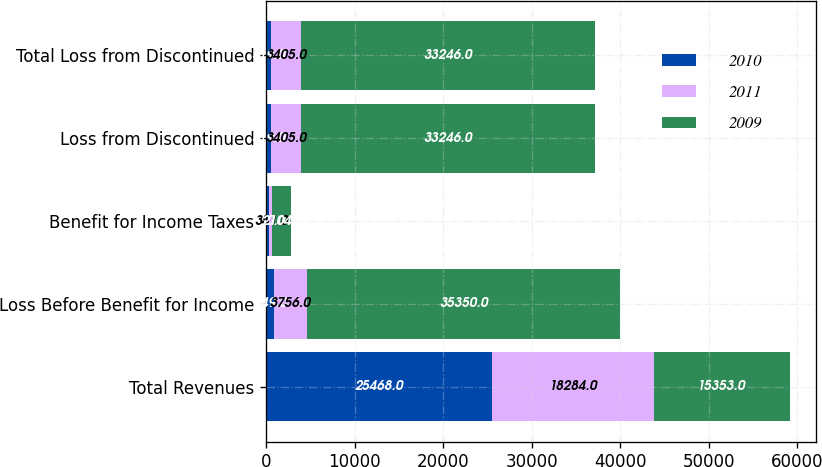Convert chart. <chart><loc_0><loc_0><loc_500><loc_500><stacked_bar_chart><ecel><fcel>Total Revenues<fcel>Loss Before Benefit for Income<fcel>Benefit for Income Taxes<fcel>Loss from Discontinued<fcel>Total Loss from Discontinued<nl><fcel>2010<fcel>25468<fcel>849<fcel>330<fcel>519<fcel>519<nl><fcel>2011<fcel>18284<fcel>3756<fcel>351<fcel>3405<fcel>3405<nl><fcel>2009<fcel>15353<fcel>35350<fcel>2104<fcel>33246<fcel>33246<nl></chart> 